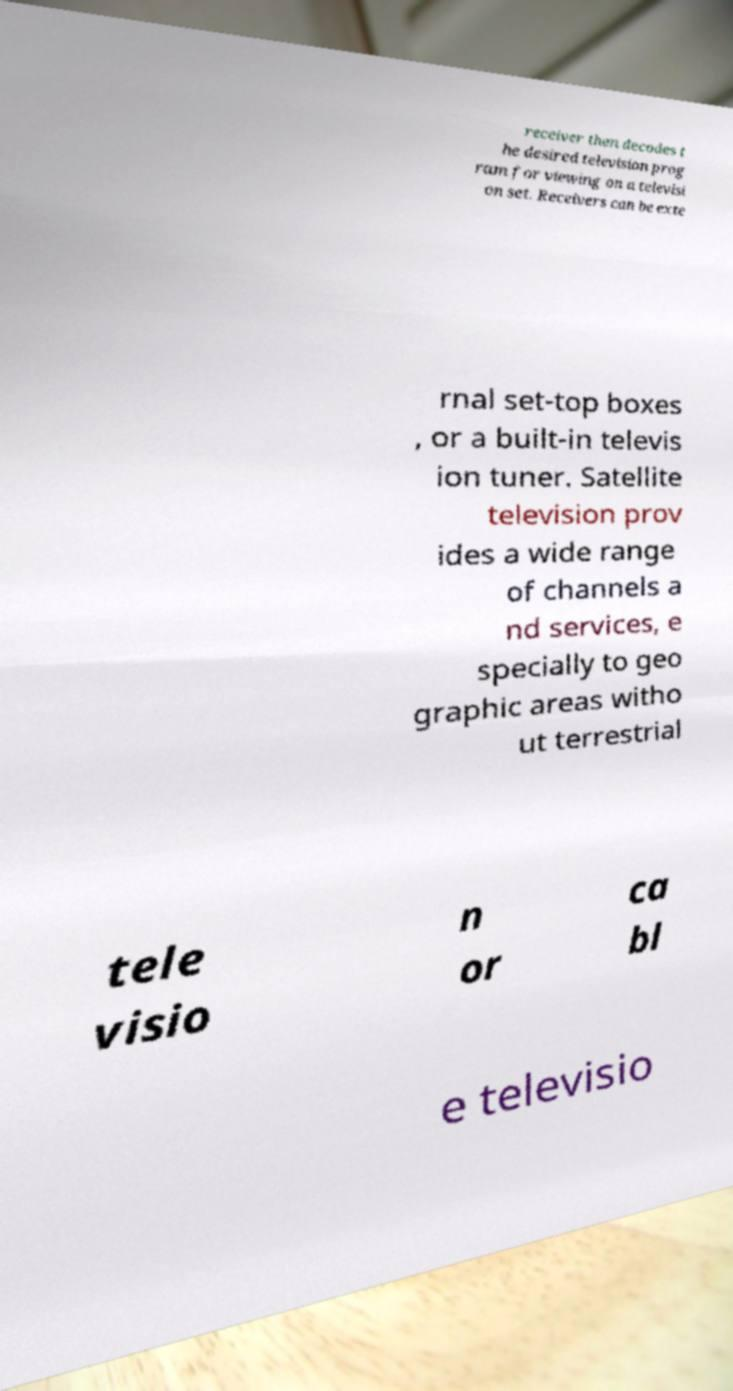What messages or text are displayed in this image? I need them in a readable, typed format. receiver then decodes t he desired television prog ram for viewing on a televisi on set. Receivers can be exte rnal set-top boxes , or a built-in televis ion tuner. Satellite television prov ides a wide range of channels a nd services, e specially to geo graphic areas witho ut terrestrial tele visio n or ca bl e televisio 